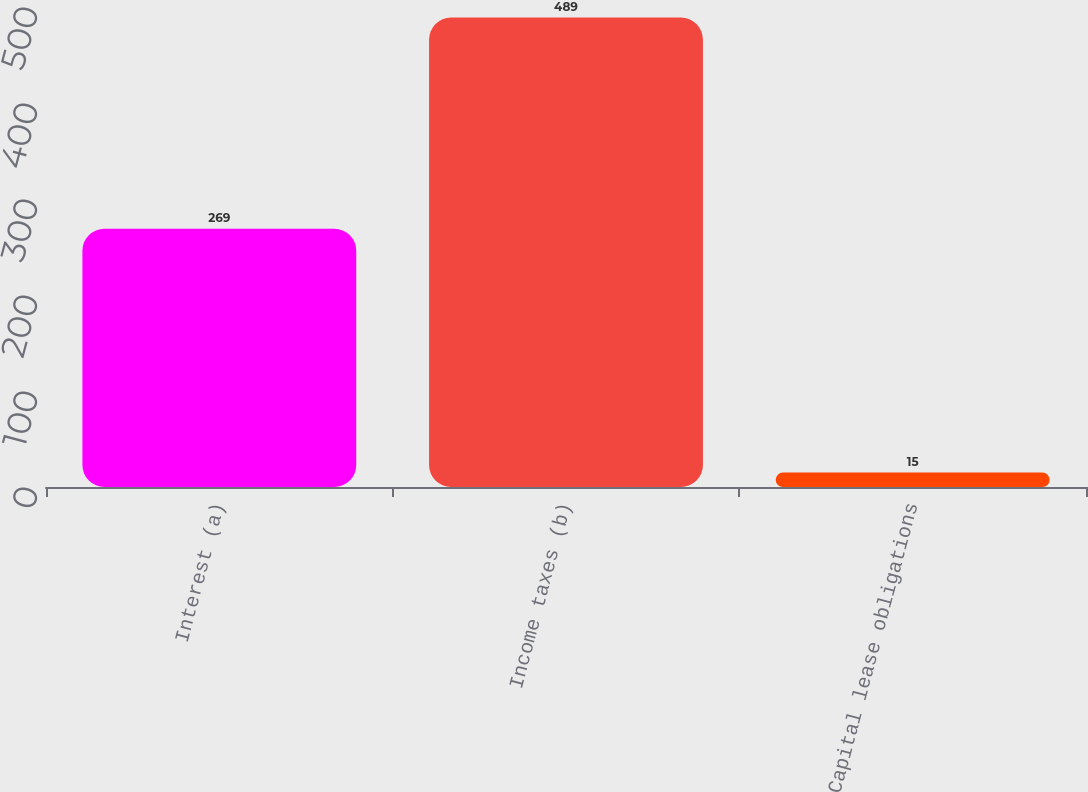Convert chart. <chart><loc_0><loc_0><loc_500><loc_500><bar_chart><fcel>Interest (a)<fcel>Income taxes (b)<fcel>Capital lease obligations<nl><fcel>269<fcel>489<fcel>15<nl></chart> 